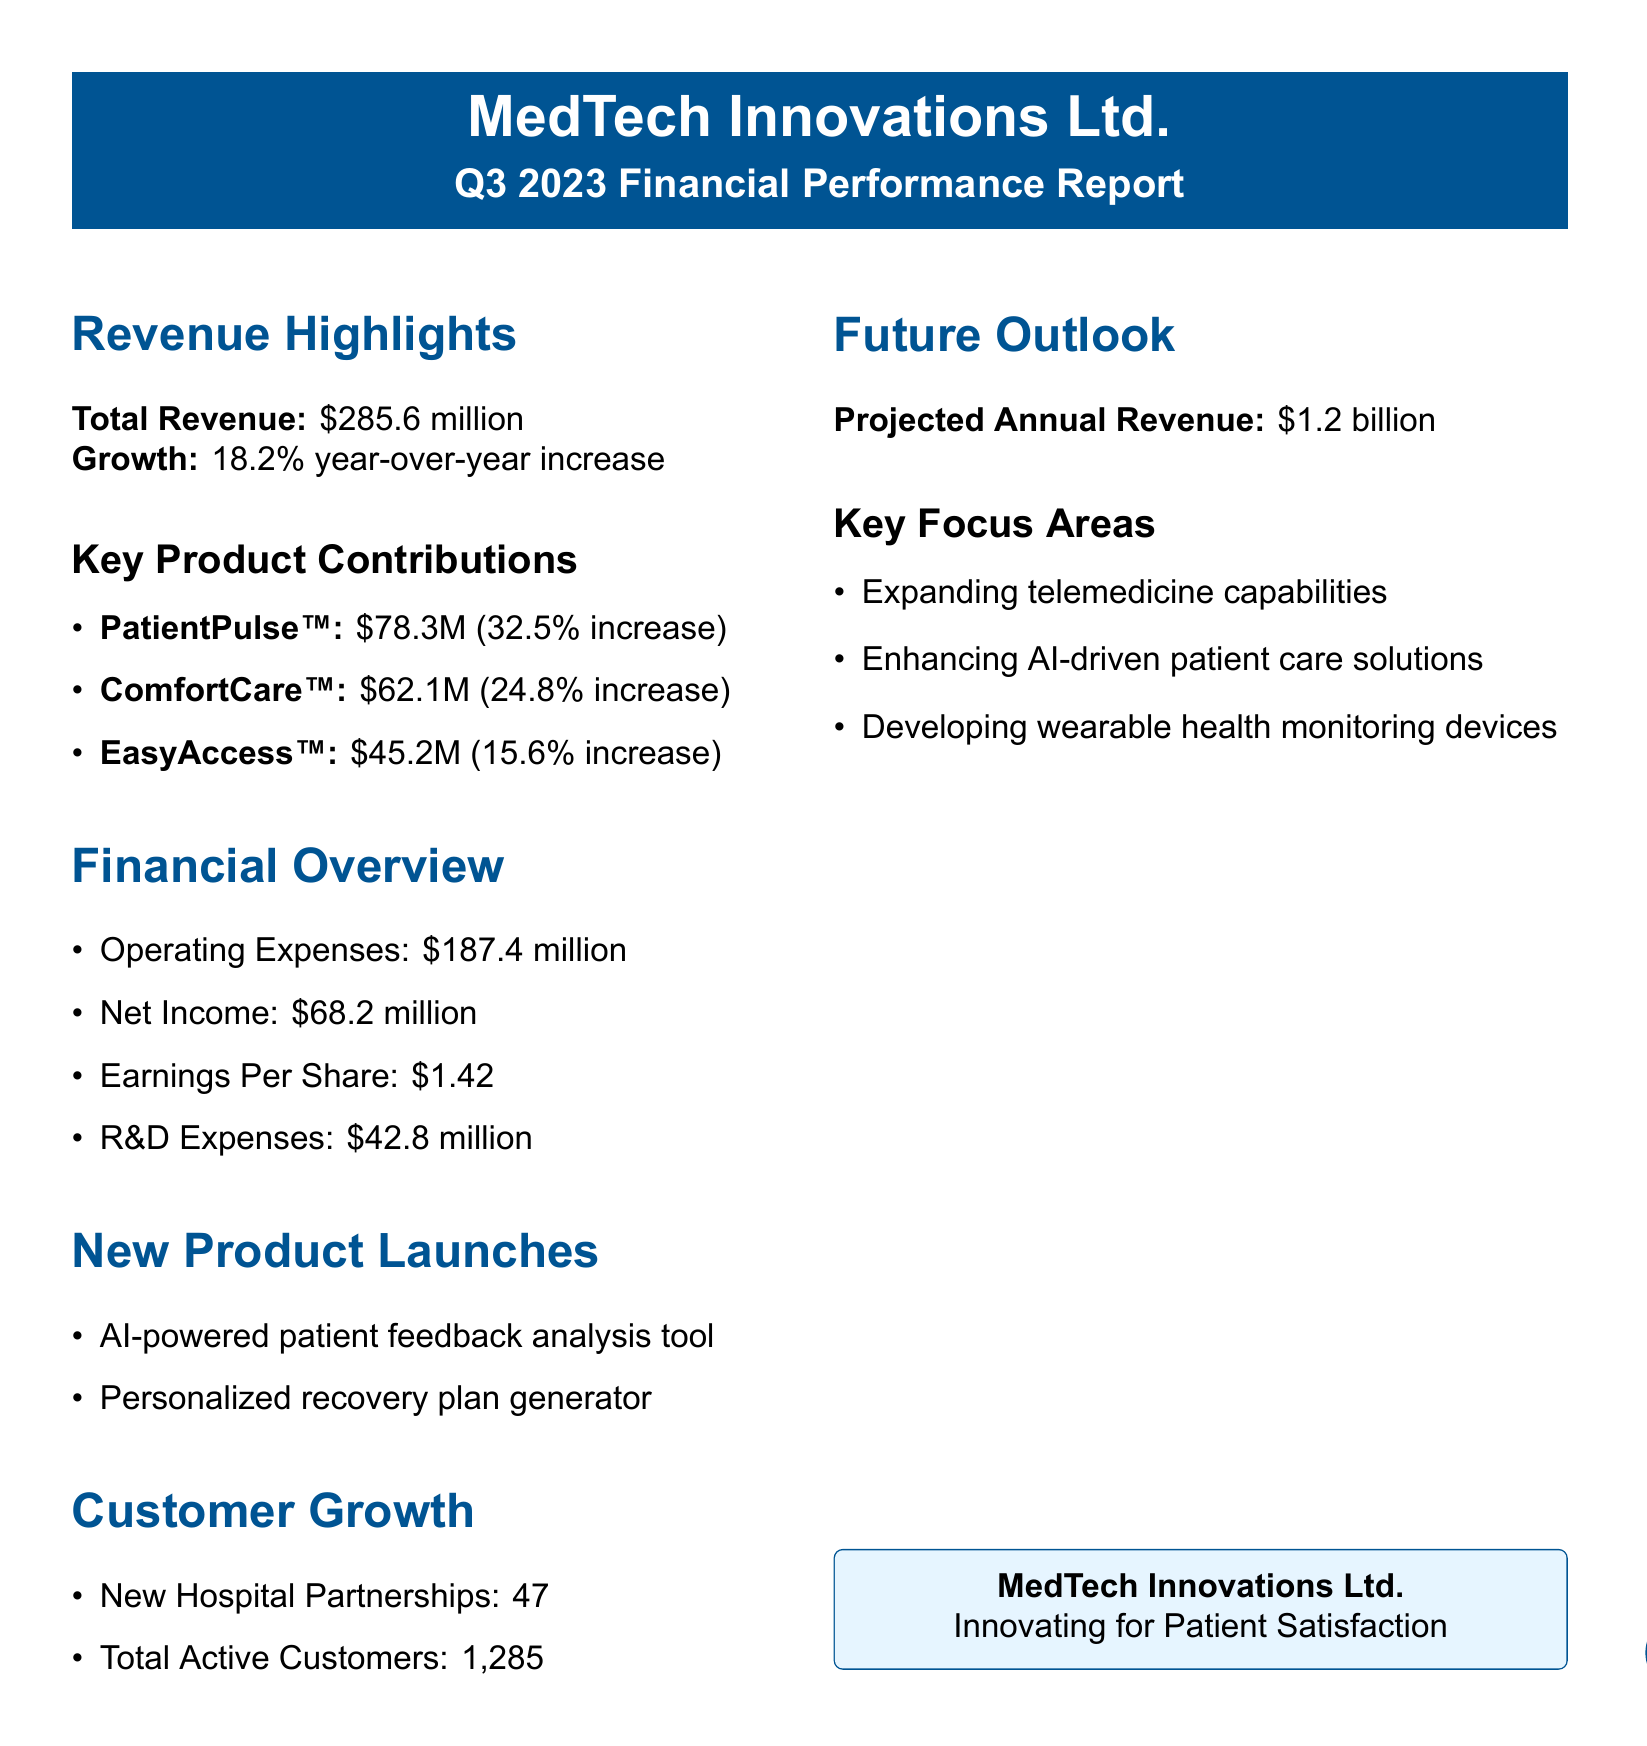what is the total revenue? The total revenue is provided in the revenue highlights section, indicating overall performance for the quarter.
Answer: $285.6 million what is the growth percentage year-over-year? This figure reflects the year-over-year revenue growth highlighted in the report, representing company performance.
Answer: 18.2% year-over-year increase how much revenue did PatientPulse™ generate? The document specifies the revenue contribution of PatientPulse™, highlighting its success as a key product.
Answer: $78.3 million how many new hospital partnerships were established? This number signifies the growth in customer relationships, detailed in the customer growth section.
Answer: 47 what is the projected annual revenue? The report outlines the expected financial performance for the upcoming year, focusing on future growth and opportunity.
Answer: $1.2 billion what are the R&D expenses for this quarter? The document lists the expenses related to research and development, which can indicate investment in innovation.
Answer: $42.8 million which product had the highest revenue growth percentage? This question requires comparing the growth figures provided for the key products to determine which one performed best.
Answer: PatientPulse™ (32.5% increase) how many total active customers does the company have? The total number of active customers is indicated in the customer growth section of the report, showing the company's reach.
Answer: 1285 what are the key focus areas for future growth? This reflects the strategic goals outlined for the company in the future outlook section, indicating areas of innovation.
Answer: Expanding telemedicine capabilities, Enhancing AI-driven patient care solutions, Developing wearable health monitoring devices 